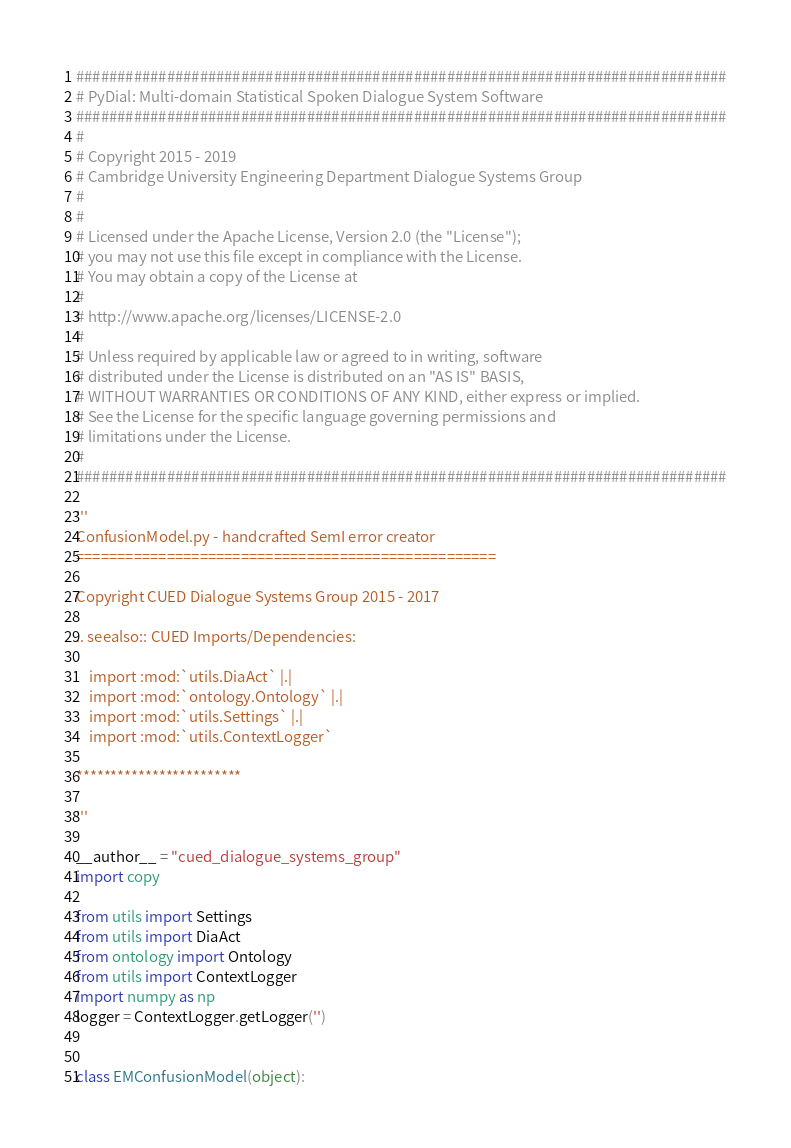Convert code to text. <code><loc_0><loc_0><loc_500><loc_500><_Python_>###############################################################################
# PyDial: Multi-domain Statistical Spoken Dialogue System Software
###############################################################################
#
# Copyright 2015 - 2019
# Cambridge University Engineering Department Dialogue Systems Group
#
# 
# Licensed under the Apache License, Version 2.0 (the "License");
# you may not use this file except in compliance with the License.
# You may obtain a copy of the License at
#
# http://www.apache.org/licenses/LICENSE-2.0
#
# Unless required by applicable law or agreed to in writing, software
# distributed under the License is distributed on an "AS IS" BASIS,
# WITHOUT WARRANTIES OR CONDITIONS OF ANY KIND, either express or implied.
# See the License for the specific language governing permissions and
# limitations under the License.
#
###############################################################################

'''
ConfusionModel.py - handcrafted SemI error creator 
===================================================

Copyright CUED Dialogue Systems Group 2015 - 2017

.. seealso:: CUED Imports/Dependencies: 

    import :mod:`utils.DiaAct` |.|
    import :mod:`ontology.Ontology` |.|
    import :mod:`utils.Settings` |.|
    import :mod:`utils.ContextLogger`

************************

''' 

__author__ = "cued_dialogue_systems_group"
import copy

from utils import Settings
from utils import DiaAct
from ontology import Ontology
from utils import ContextLogger
import numpy as np
logger = ContextLogger.getLogger('')


class EMConfusionModel(object):</code> 